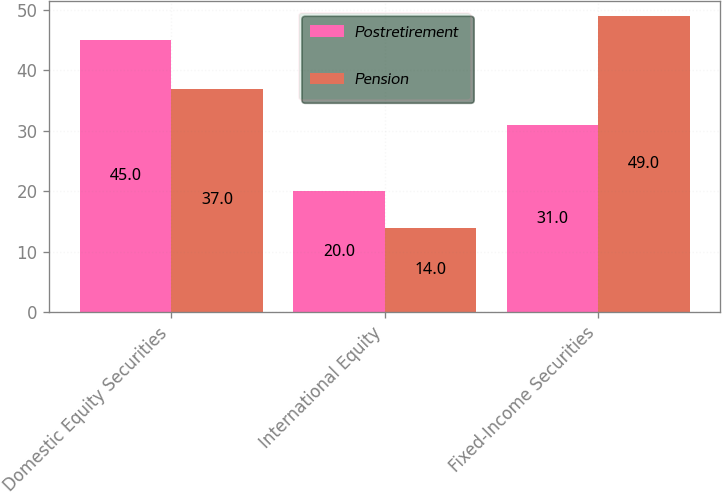Convert chart to OTSL. <chart><loc_0><loc_0><loc_500><loc_500><stacked_bar_chart><ecel><fcel>Domestic Equity Securities<fcel>International Equity<fcel>Fixed-Income Securities<nl><fcel>Postretirement<fcel>45<fcel>20<fcel>31<nl><fcel>Pension<fcel>37<fcel>14<fcel>49<nl></chart> 